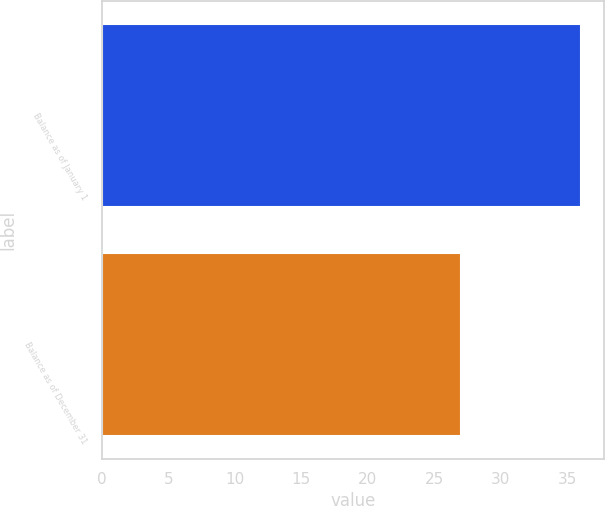Convert chart. <chart><loc_0><loc_0><loc_500><loc_500><bar_chart><fcel>Balance as of January 1<fcel>Balance as of December 31<nl><fcel>36<fcel>27<nl></chart> 